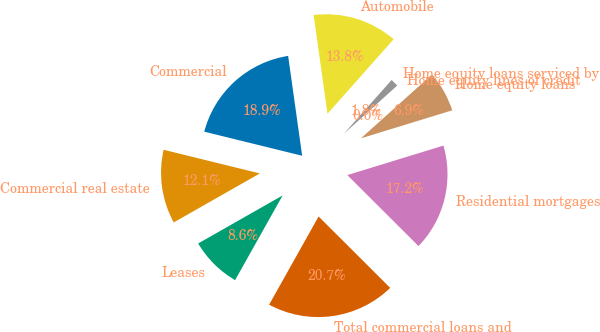Convert chart to OTSL. <chart><loc_0><loc_0><loc_500><loc_500><pie_chart><fcel>Commercial<fcel>Commercial real estate<fcel>Leases<fcel>Total commercial loans and<fcel>Residential mortgages<fcel>Home equity loans<fcel>Home equity lines of credit<fcel>Home equity loans serviced by<fcel>Automobile<nl><fcel>18.94%<fcel>12.07%<fcel>8.63%<fcel>20.66%<fcel>17.22%<fcel>6.91%<fcel>0.04%<fcel>1.75%<fcel>13.78%<nl></chart> 